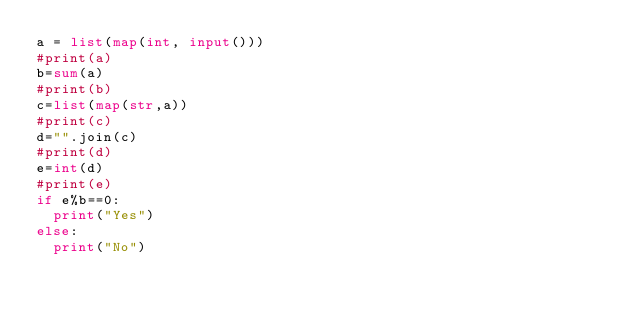<code> <loc_0><loc_0><loc_500><loc_500><_Python_>a = list(map(int, input()))
#print(a)
b=sum(a)
#print(b)
c=list(map(str,a))
#print(c)
d="".join(c)
#print(d)
e=int(d)
#print(e)
if e%b==0:
	print("Yes")
else:
	print("No")
</code> 